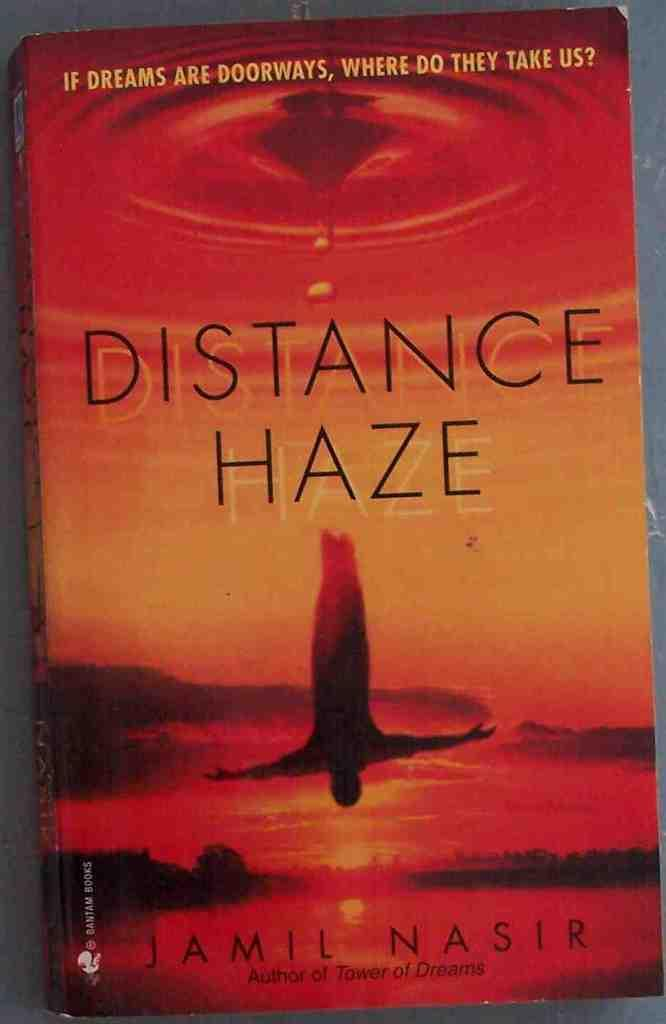Provide a one-sentence caption for the provided image. A book by Jamil Nasir with an orange/red cover. 